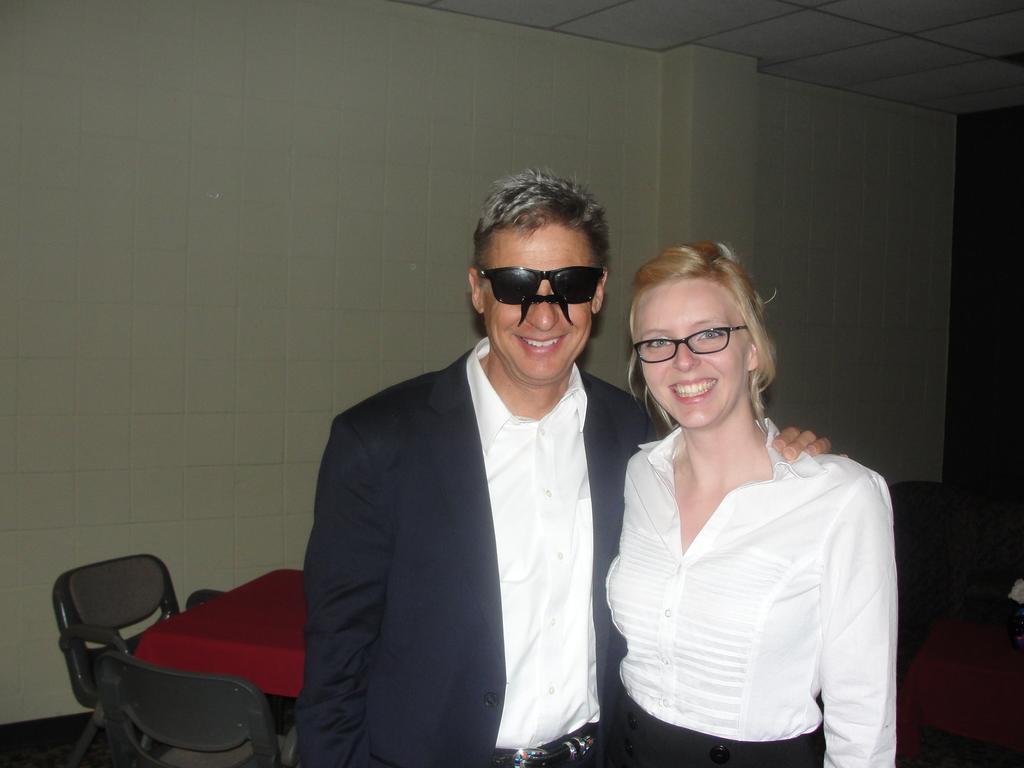Describe this image in one or two sentences. In the center of the image there are two people. On the right there is a lady who is wearing a white shirt is laughing, next to her there is a man. Behind him there is a table and chairs. In the background we can see a wall. 